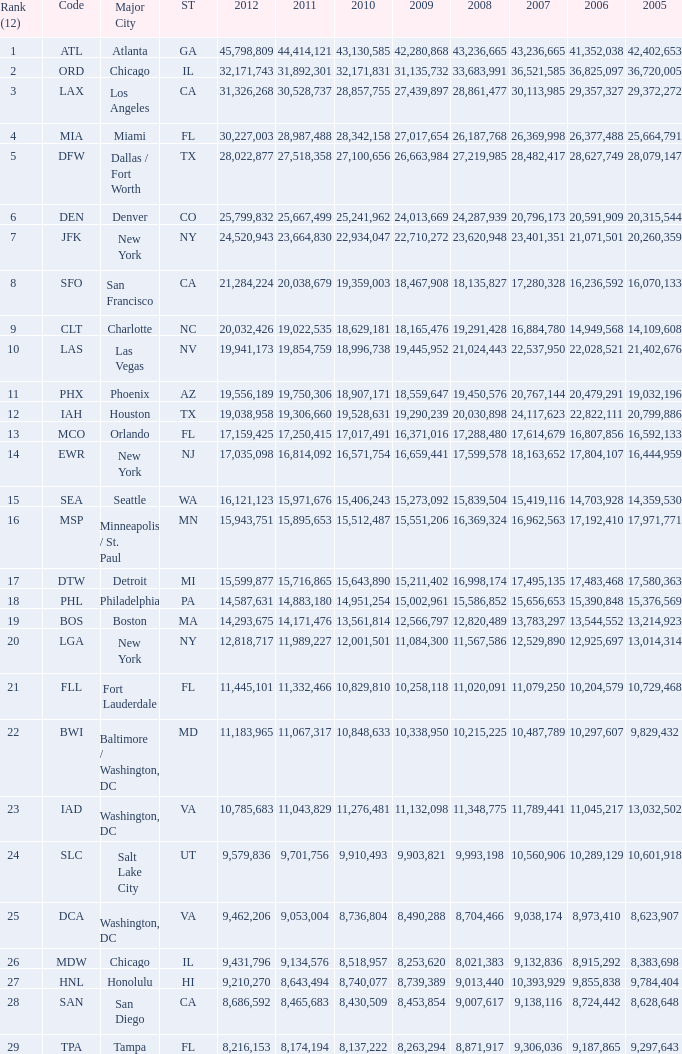What is the greatest 2010 for Miami, Fl? 28342158.0. 